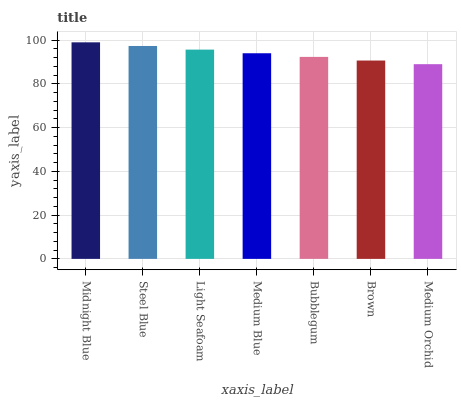Is Steel Blue the minimum?
Answer yes or no. No. Is Steel Blue the maximum?
Answer yes or no. No. Is Midnight Blue greater than Steel Blue?
Answer yes or no. Yes. Is Steel Blue less than Midnight Blue?
Answer yes or no. Yes. Is Steel Blue greater than Midnight Blue?
Answer yes or no. No. Is Midnight Blue less than Steel Blue?
Answer yes or no. No. Is Medium Blue the high median?
Answer yes or no. Yes. Is Medium Blue the low median?
Answer yes or no. Yes. Is Midnight Blue the high median?
Answer yes or no. No. Is Steel Blue the low median?
Answer yes or no. No. 